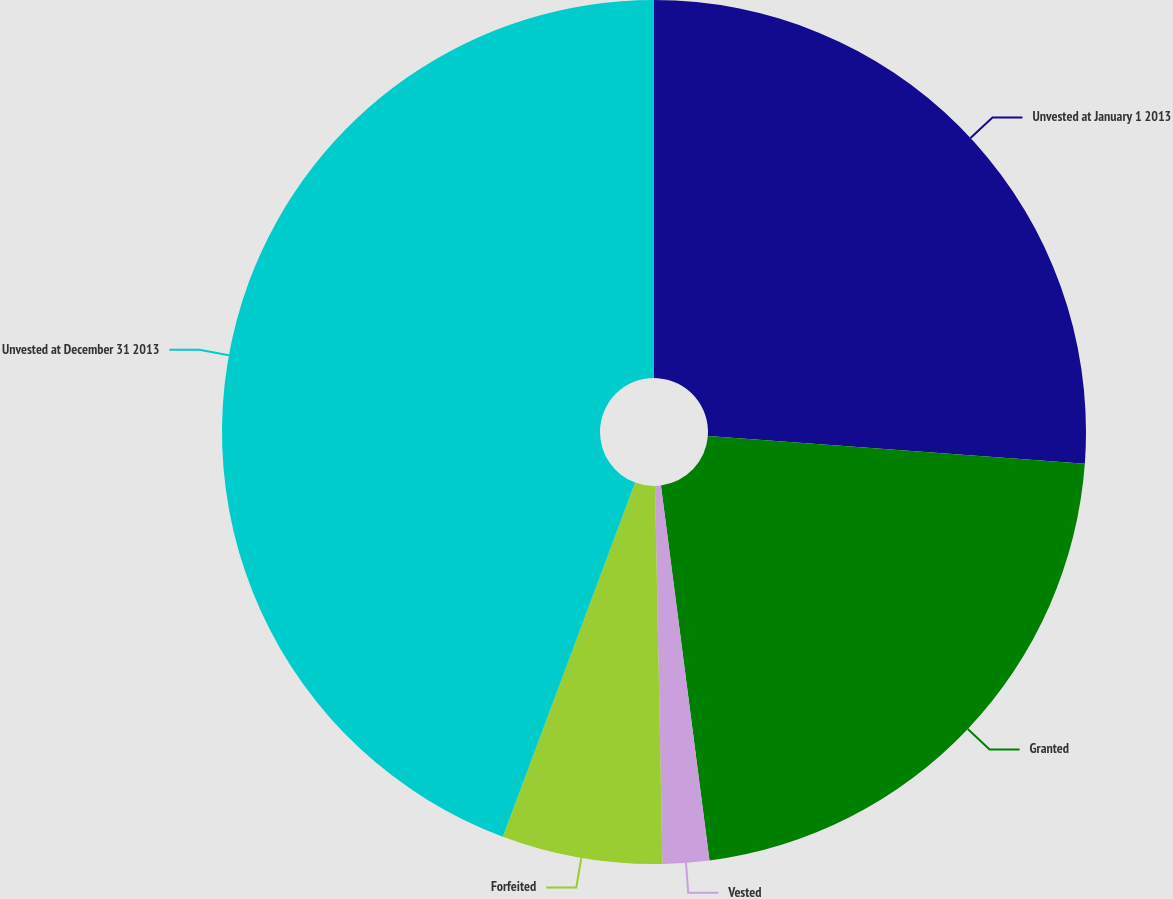<chart> <loc_0><loc_0><loc_500><loc_500><pie_chart><fcel>Unvested at January 1 2013<fcel>Granted<fcel>Vested<fcel>Forfeited<fcel>Unvested at December 31 2013<nl><fcel>26.17%<fcel>21.78%<fcel>1.74%<fcel>6.0%<fcel>44.31%<nl></chart> 